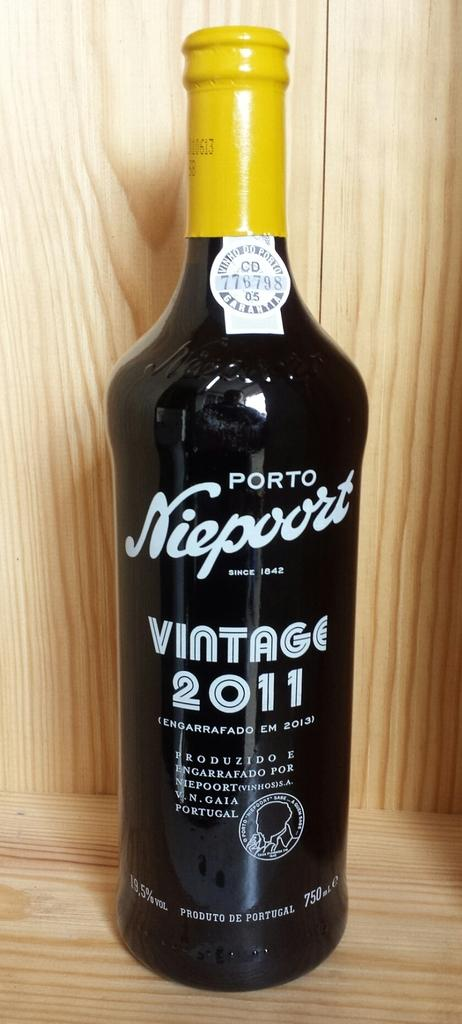<image>
Relay a brief, clear account of the picture shown. Black bottle that says "Vintage 2011" on the front. 